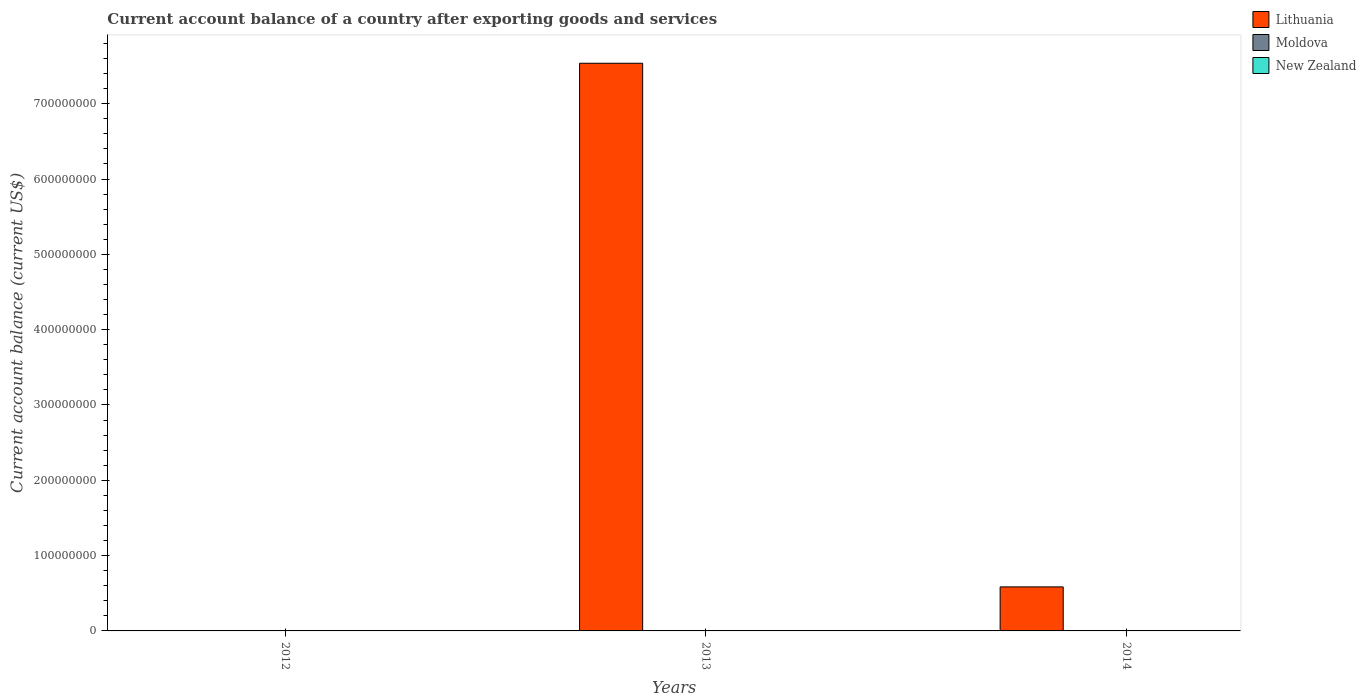How many different coloured bars are there?
Offer a terse response. 1. How many bars are there on the 1st tick from the right?
Make the answer very short. 1. In how many cases, is the number of bars for a given year not equal to the number of legend labels?
Give a very brief answer. 3. Across all years, what is the maximum account balance in Lithuania?
Keep it short and to the point. 7.54e+08. Across all years, what is the minimum account balance in Lithuania?
Ensure brevity in your answer.  0. What is the total account balance in New Zealand in the graph?
Provide a succinct answer. 0. What is the difference between the account balance in Lithuania in 2013 and that in 2014?
Provide a short and direct response. 6.95e+08. What is the difference between the account balance in New Zealand in 2012 and the account balance in Lithuania in 2013?
Provide a short and direct response. -7.54e+08. What is the average account balance in New Zealand per year?
Provide a succinct answer. 0. What is the ratio of the account balance in Lithuania in 2013 to that in 2014?
Keep it short and to the point. 12.89. What is the difference between the highest and the lowest account balance in Lithuania?
Your answer should be compact. 7.54e+08. Is it the case that in every year, the sum of the account balance in Lithuania and account balance in New Zealand is greater than the account balance in Moldova?
Ensure brevity in your answer.  No. How many bars are there?
Provide a succinct answer. 2. How many years are there in the graph?
Provide a succinct answer. 3. Does the graph contain any zero values?
Ensure brevity in your answer.  Yes. Where does the legend appear in the graph?
Your response must be concise. Top right. How many legend labels are there?
Provide a short and direct response. 3. How are the legend labels stacked?
Keep it short and to the point. Vertical. What is the title of the graph?
Provide a short and direct response. Current account balance of a country after exporting goods and services. Does "South Africa" appear as one of the legend labels in the graph?
Your response must be concise. No. What is the label or title of the Y-axis?
Provide a short and direct response. Current account balance (current US$). What is the Current account balance (current US$) of Lithuania in 2012?
Provide a short and direct response. 0. What is the Current account balance (current US$) of Lithuania in 2013?
Offer a terse response. 7.54e+08. What is the Current account balance (current US$) of Lithuania in 2014?
Your answer should be very brief. 5.85e+07. What is the Current account balance (current US$) in Moldova in 2014?
Keep it short and to the point. 0. Across all years, what is the maximum Current account balance (current US$) of Lithuania?
Provide a succinct answer. 7.54e+08. Across all years, what is the minimum Current account balance (current US$) of Lithuania?
Provide a short and direct response. 0. What is the total Current account balance (current US$) in Lithuania in the graph?
Offer a terse response. 8.12e+08. What is the total Current account balance (current US$) of Moldova in the graph?
Your answer should be very brief. 0. What is the total Current account balance (current US$) of New Zealand in the graph?
Your answer should be compact. 0. What is the difference between the Current account balance (current US$) in Lithuania in 2013 and that in 2014?
Your response must be concise. 6.95e+08. What is the average Current account balance (current US$) of Lithuania per year?
Keep it short and to the point. 2.71e+08. What is the average Current account balance (current US$) in Moldova per year?
Offer a very short reply. 0. What is the ratio of the Current account balance (current US$) of Lithuania in 2013 to that in 2014?
Provide a short and direct response. 12.89. What is the difference between the highest and the lowest Current account balance (current US$) of Lithuania?
Offer a terse response. 7.54e+08. 